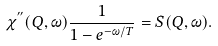Convert formula to latex. <formula><loc_0><loc_0><loc_500><loc_500>\chi ^ { ^ { \prime \prime } } ( { Q } , \omega ) \frac { 1 } { 1 - e ^ { - \omega / T } } = S ( { Q } , \omega ) .</formula> 